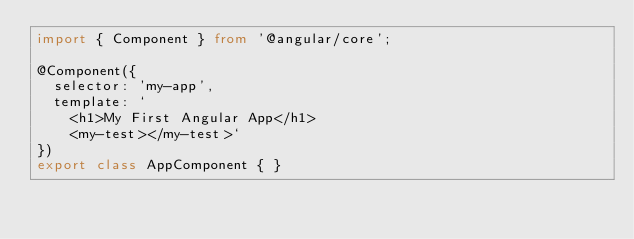<code> <loc_0><loc_0><loc_500><loc_500><_TypeScript_>import { Component } from '@angular/core';

@Component({
  selector: 'my-app',
  template: `
    <h1>My First Angular App</h1>
    <my-test></my-test>`
})
export class AppComponent { }
</code> 